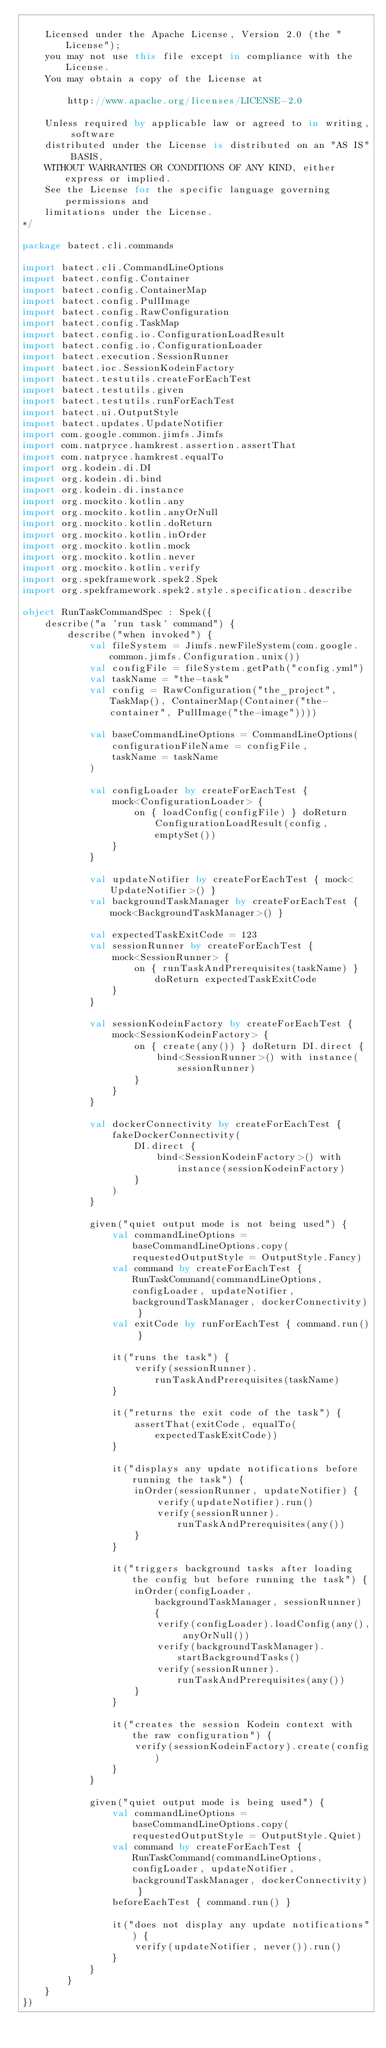Convert code to text. <code><loc_0><loc_0><loc_500><loc_500><_Kotlin_>
    Licensed under the Apache License, Version 2.0 (the "License");
    you may not use this file except in compliance with the License.
    You may obtain a copy of the License at

        http://www.apache.org/licenses/LICENSE-2.0

    Unless required by applicable law or agreed to in writing, software
    distributed under the License is distributed on an "AS IS" BASIS,
    WITHOUT WARRANTIES OR CONDITIONS OF ANY KIND, either express or implied.
    See the License for the specific language governing permissions and
    limitations under the License.
*/

package batect.cli.commands

import batect.cli.CommandLineOptions
import batect.config.Container
import batect.config.ContainerMap
import batect.config.PullImage
import batect.config.RawConfiguration
import batect.config.TaskMap
import batect.config.io.ConfigurationLoadResult
import batect.config.io.ConfigurationLoader
import batect.execution.SessionRunner
import batect.ioc.SessionKodeinFactory
import batect.testutils.createForEachTest
import batect.testutils.given
import batect.testutils.runForEachTest
import batect.ui.OutputStyle
import batect.updates.UpdateNotifier
import com.google.common.jimfs.Jimfs
import com.natpryce.hamkrest.assertion.assertThat
import com.natpryce.hamkrest.equalTo
import org.kodein.di.DI
import org.kodein.di.bind
import org.kodein.di.instance
import org.mockito.kotlin.any
import org.mockito.kotlin.anyOrNull
import org.mockito.kotlin.doReturn
import org.mockito.kotlin.inOrder
import org.mockito.kotlin.mock
import org.mockito.kotlin.never
import org.mockito.kotlin.verify
import org.spekframework.spek2.Spek
import org.spekframework.spek2.style.specification.describe

object RunTaskCommandSpec : Spek({
    describe("a 'run task' command") {
        describe("when invoked") {
            val fileSystem = Jimfs.newFileSystem(com.google.common.jimfs.Configuration.unix())
            val configFile = fileSystem.getPath("config.yml")
            val taskName = "the-task"
            val config = RawConfiguration("the_project", TaskMap(), ContainerMap(Container("the-container", PullImage("the-image"))))

            val baseCommandLineOptions = CommandLineOptions(
                configurationFileName = configFile,
                taskName = taskName
            )

            val configLoader by createForEachTest {
                mock<ConfigurationLoader> {
                    on { loadConfig(configFile) } doReturn ConfigurationLoadResult(config, emptySet())
                }
            }

            val updateNotifier by createForEachTest { mock<UpdateNotifier>() }
            val backgroundTaskManager by createForEachTest { mock<BackgroundTaskManager>() }

            val expectedTaskExitCode = 123
            val sessionRunner by createForEachTest {
                mock<SessionRunner> {
                    on { runTaskAndPrerequisites(taskName) } doReturn expectedTaskExitCode
                }
            }

            val sessionKodeinFactory by createForEachTest {
                mock<SessionKodeinFactory> {
                    on { create(any()) } doReturn DI.direct {
                        bind<SessionRunner>() with instance(sessionRunner)
                    }
                }
            }

            val dockerConnectivity by createForEachTest {
                fakeDockerConnectivity(
                    DI.direct {
                        bind<SessionKodeinFactory>() with instance(sessionKodeinFactory)
                    }
                )
            }

            given("quiet output mode is not being used") {
                val commandLineOptions = baseCommandLineOptions.copy(requestedOutputStyle = OutputStyle.Fancy)
                val command by createForEachTest { RunTaskCommand(commandLineOptions, configLoader, updateNotifier, backgroundTaskManager, dockerConnectivity) }
                val exitCode by runForEachTest { command.run() }

                it("runs the task") {
                    verify(sessionRunner).runTaskAndPrerequisites(taskName)
                }

                it("returns the exit code of the task") {
                    assertThat(exitCode, equalTo(expectedTaskExitCode))
                }

                it("displays any update notifications before running the task") {
                    inOrder(sessionRunner, updateNotifier) {
                        verify(updateNotifier).run()
                        verify(sessionRunner).runTaskAndPrerequisites(any())
                    }
                }

                it("triggers background tasks after loading the config but before running the task") {
                    inOrder(configLoader, backgroundTaskManager, sessionRunner) {
                        verify(configLoader).loadConfig(any(), anyOrNull())
                        verify(backgroundTaskManager).startBackgroundTasks()
                        verify(sessionRunner).runTaskAndPrerequisites(any())
                    }
                }

                it("creates the session Kodein context with the raw configuration") {
                    verify(sessionKodeinFactory).create(config)
                }
            }

            given("quiet output mode is being used") {
                val commandLineOptions = baseCommandLineOptions.copy(requestedOutputStyle = OutputStyle.Quiet)
                val command by createForEachTest { RunTaskCommand(commandLineOptions, configLoader, updateNotifier, backgroundTaskManager, dockerConnectivity) }
                beforeEachTest { command.run() }

                it("does not display any update notifications") {
                    verify(updateNotifier, never()).run()
                }
            }
        }
    }
})
</code> 